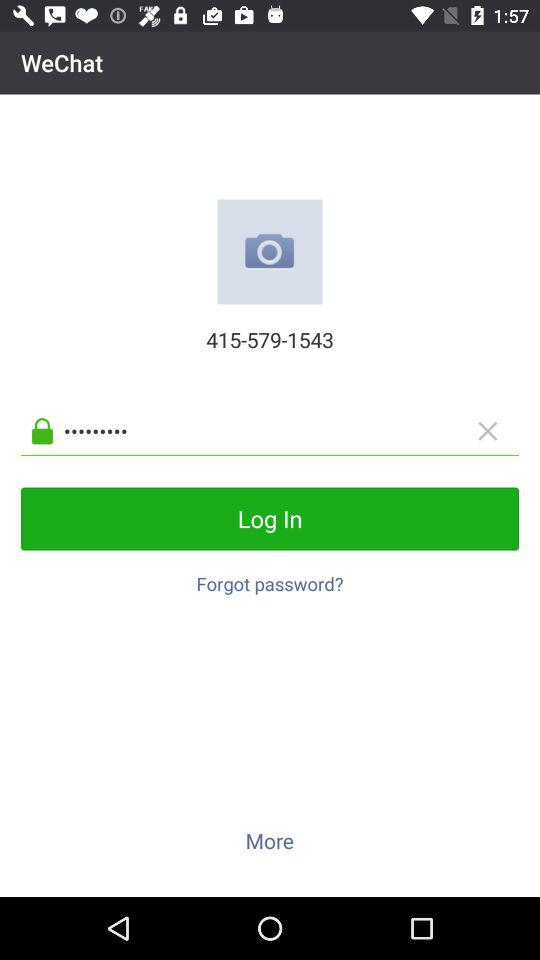"WeChat" is powered by who?
When the provided information is insufficient, respond with <no answer>. <no answer> 